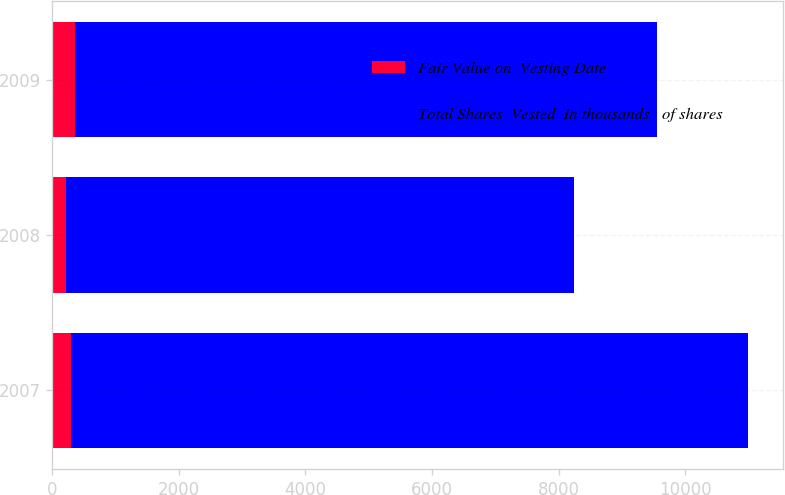Convert chart to OTSL. <chart><loc_0><loc_0><loc_500><loc_500><stacked_bar_chart><ecel><fcel>2007<fcel>2008<fcel>2009<nl><fcel>Fair Value on  Vesting Date<fcel>305<fcel>224<fcel>366<nl><fcel>Total Shares  Vested  In thousands   of shares<fcel>10686<fcel>8018<fcel>9190<nl></chart> 